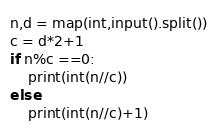Convert code to text. <code><loc_0><loc_0><loc_500><loc_500><_Python_>n,d = map(int,input().split())
c = d*2+1
if n%c ==0:
    print(int(n//c))
else:
    print(int(n//c)+1)</code> 